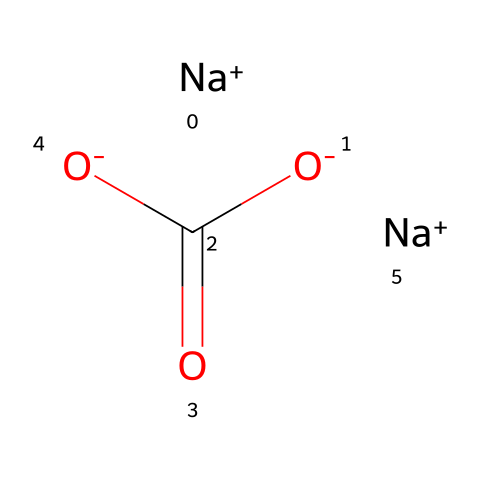How many sodium atoms are present in this structure? The SMILES representation shows two instances of [Na+], indicating that there are two sodium atoms in the structure.
Answer: 2 What functional groups are present in this chemical? The structure contains carboxylate groups as indicated by the [O-]C(=O)[O-] part of the SMILES, showing the presence of carboxylic acid derivatives.
Answer: carboxylate group How many oxygen atoms are in this molecule? By examining the structure, we can identify there are a total of three oxygen atoms: one from the carboxylate part and two from [O-].
Answer: 3 What is the charge of the sodium ions in the structure? The structure includes [Na+], which indicates that each sodium ion carries a positive charge.
Answer: positive Why is sodium carbonate effective in cleaning solutions? Sodium carbonate has a basic nature, which helps to break down dirt and grease, making it effective as a cleaning agent. This is inferred from its chemical properties and usage rather than just its structure.
Answer: basic nature What type of chemical is sodium carbonate classified as? Sodium carbonate is classified as a salt due to its formation from the reaction of an acid (carbonic acid) and a base (sodium hydroxide).
Answer: salt 